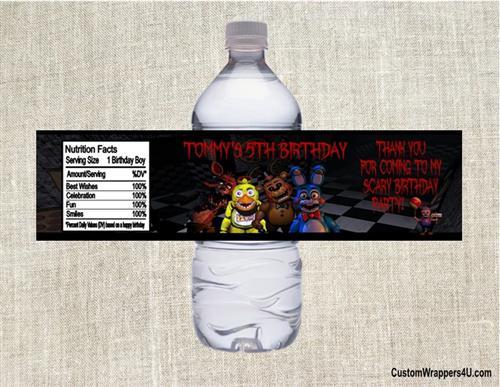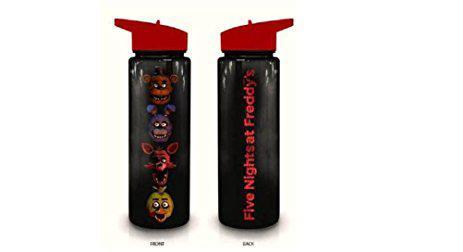The first image is the image on the left, the second image is the image on the right. Assess this claim about the two images: "Both images contain one mostly black reusable water bottle.". Correct or not? Answer yes or no. No. The first image is the image on the left, the second image is the image on the right. Given the left and right images, does the statement "The left and right image contains a total of two black bottles." hold true? Answer yes or no. Yes. 